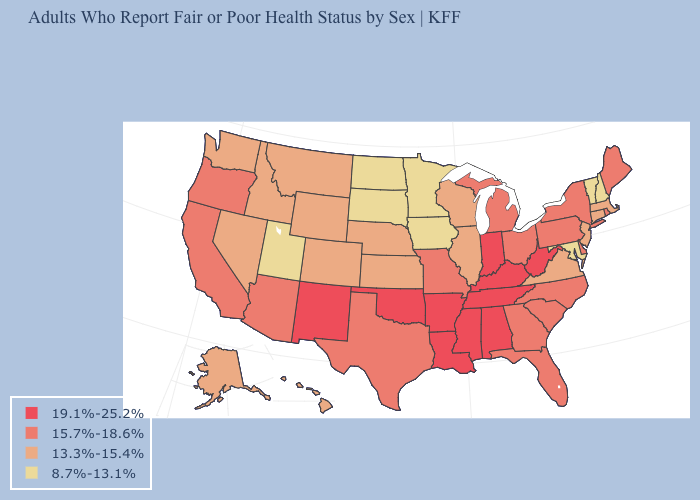What is the highest value in the USA?
Short answer required. 19.1%-25.2%. Is the legend a continuous bar?
Concise answer only. No. What is the value of Massachusetts?
Concise answer only. 13.3%-15.4%. Which states have the highest value in the USA?
Write a very short answer. Alabama, Arkansas, Indiana, Kentucky, Louisiana, Mississippi, New Mexico, Oklahoma, Tennessee, West Virginia. Name the states that have a value in the range 13.3%-15.4%?
Short answer required. Alaska, Colorado, Connecticut, Hawaii, Idaho, Illinois, Kansas, Massachusetts, Montana, Nebraska, Nevada, New Jersey, Virginia, Washington, Wisconsin, Wyoming. What is the value of New Jersey?
Be succinct. 13.3%-15.4%. Name the states that have a value in the range 19.1%-25.2%?
Write a very short answer. Alabama, Arkansas, Indiana, Kentucky, Louisiana, Mississippi, New Mexico, Oklahoma, Tennessee, West Virginia. Does the first symbol in the legend represent the smallest category?
Write a very short answer. No. What is the highest value in states that border Idaho?
Quick response, please. 15.7%-18.6%. Name the states that have a value in the range 15.7%-18.6%?
Quick response, please. Arizona, California, Delaware, Florida, Georgia, Maine, Michigan, Missouri, New York, North Carolina, Ohio, Oregon, Pennsylvania, Rhode Island, South Carolina, Texas. Name the states that have a value in the range 19.1%-25.2%?
Write a very short answer. Alabama, Arkansas, Indiana, Kentucky, Louisiana, Mississippi, New Mexico, Oklahoma, Tennessee, West Virginia. Among the states that border Florida , does Georgia have the highest value?
Keep it brief. No. What is the value of Vermont?
Give a very brief answer. 8.7%-13.1%. Does the first symbol in the legend represent the smallest category?
Keep it brief. No. Name the states that have a value in the range 15.7%-18.6%?
Answer briefly. Arizona, California, Delaware, Florida, Georgia, Maine, Michigan, Missouri, New York, North Carolina, Ohio, Oregon, Pennsylvania, Rhode Island, South Carolina, Texas. 